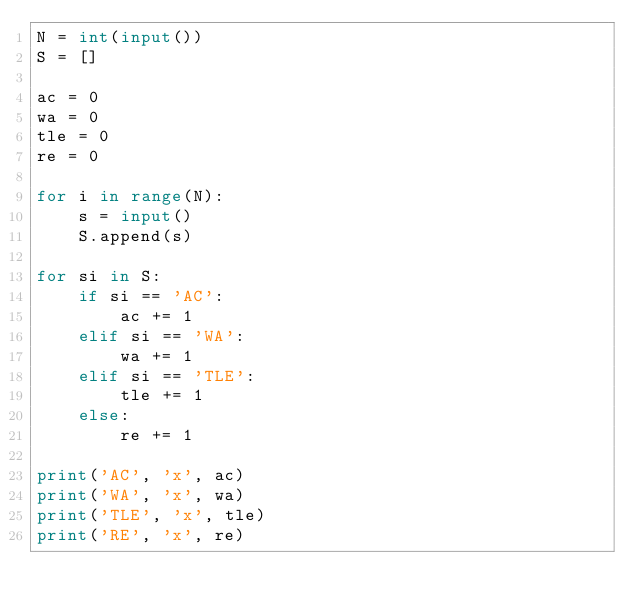Convert code to text. <code><loc_0><loc_0><loc_500><loc_500><_Python_>N = int(input())
S = []

ac = 0
wa = 0
tle = 0
re = 0

for i in range(N):
    s = input()
    S.append(s)

for si in S:
    if si == 'AC':
        ac += 1
    elif si == 'WA':
        wa += 1
    elif si == 'TLE':
        tle += 1
    else:
        re += 1

print('AC', 'x', ac)
print('WA', 'x', wa)
print('TLE', 'x', tle)
print('RE', 'x', re)
</code> 